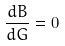<formula> <loc_0><loc_0><loc_500><loc_500>\frac { d B } { d G } = 0</formula> 